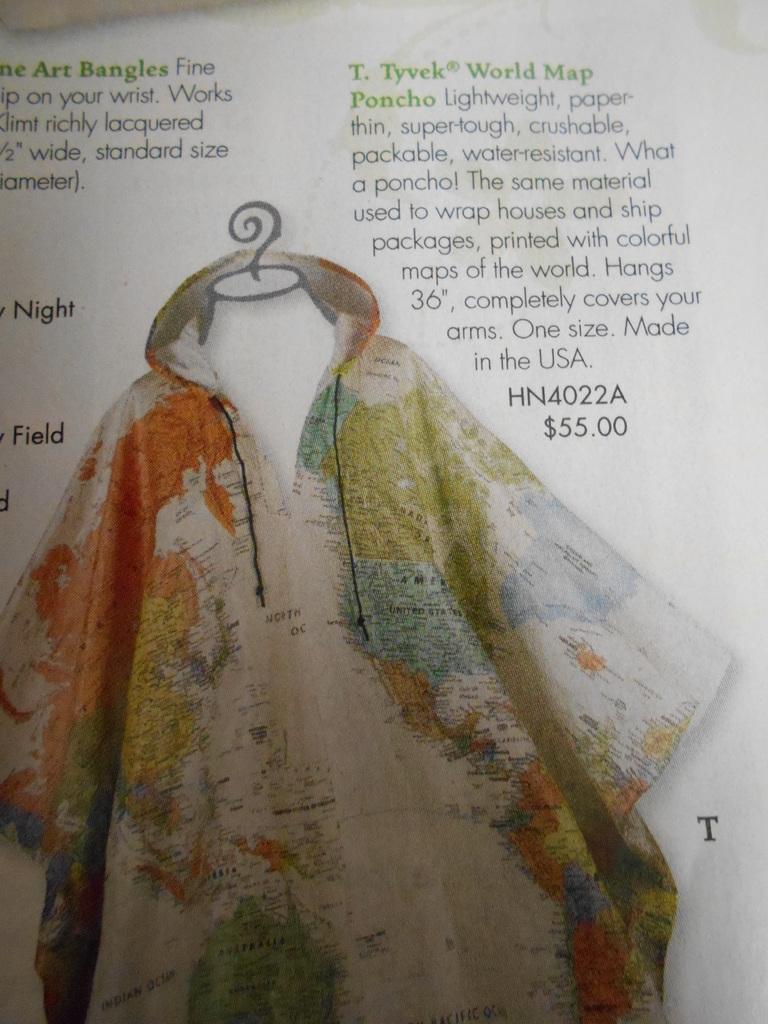Describe this image in one or two sentences. It is a paper, there is an image in the shape of shirt with the world map and there is the matter in this image. 